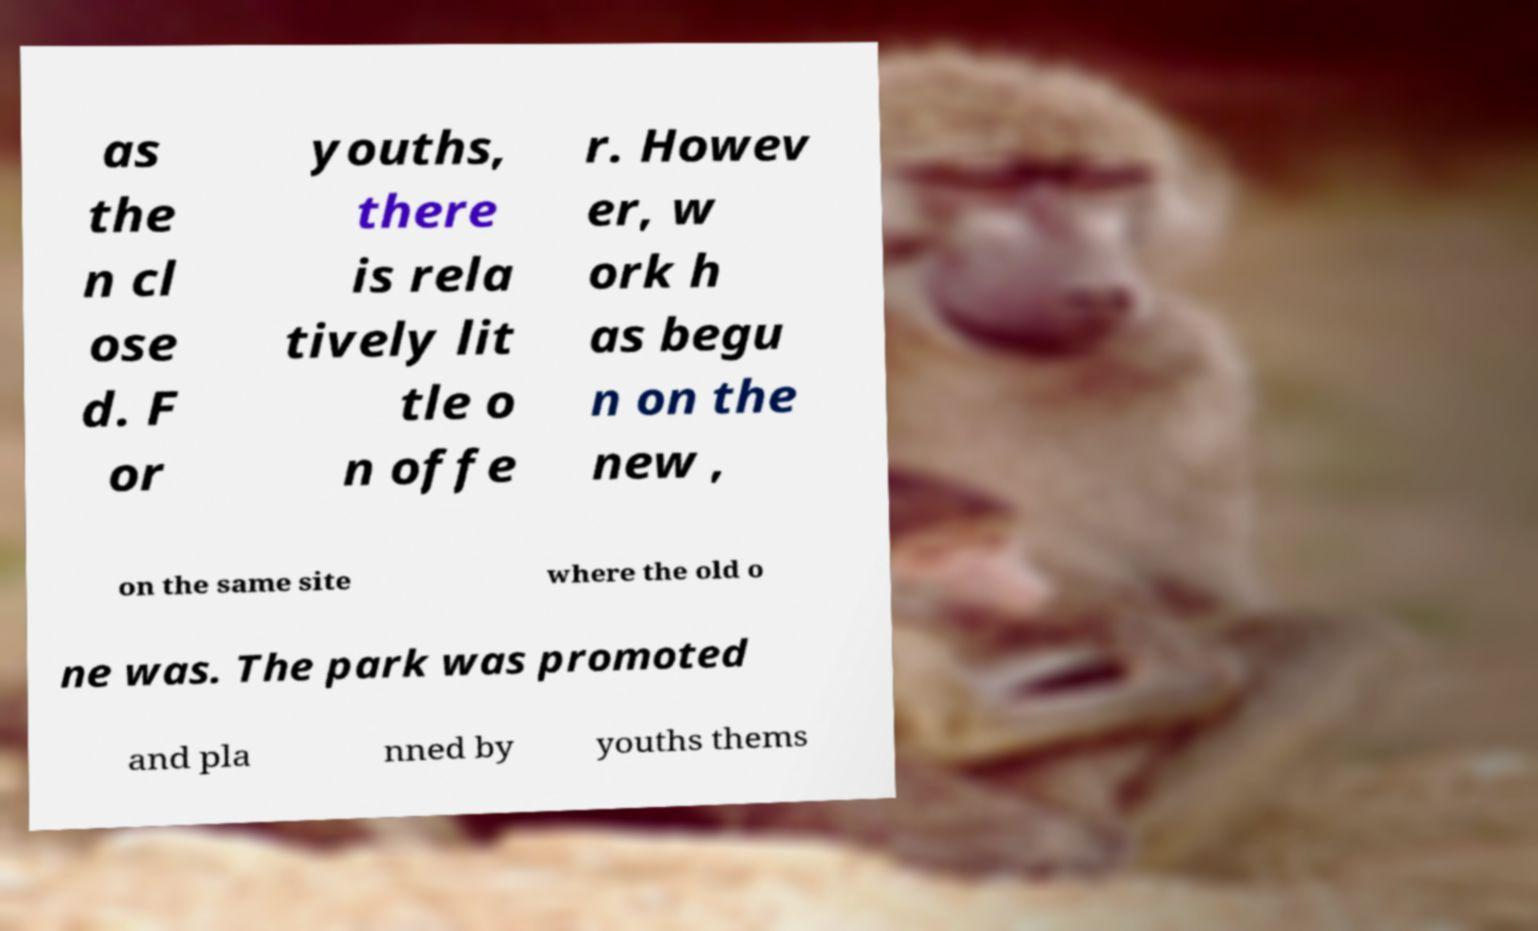Could you assist in decoding the text presented in this image and type it out clearly? as the n cl ose d. F or youths, there is rela tively lit tle o n offe r. Howev er, w ork h as begu n on the new , on the same site where the old o ne was. The park was promoted and pla nned by youths thems 